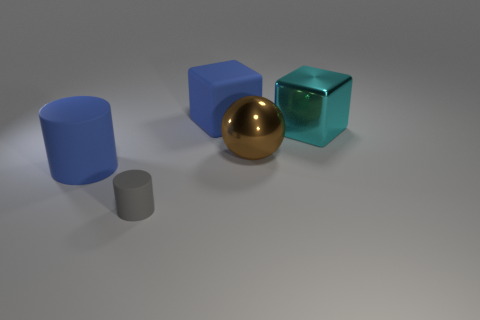Add 4 matte cylinders. How many objects exist? 9 Subtract all cubes. How many objects are left? 3 Add 1 tiny gray matte things. How many tiny gray matte things exist? 2 Subtract 0 green balls. How many objects are left? 5 Subtract all gray matte things. Subtract all large metallic objects. How many objects are left? 2 Add 1 big shiny cubes. How many big shiny cubes are left? 2 